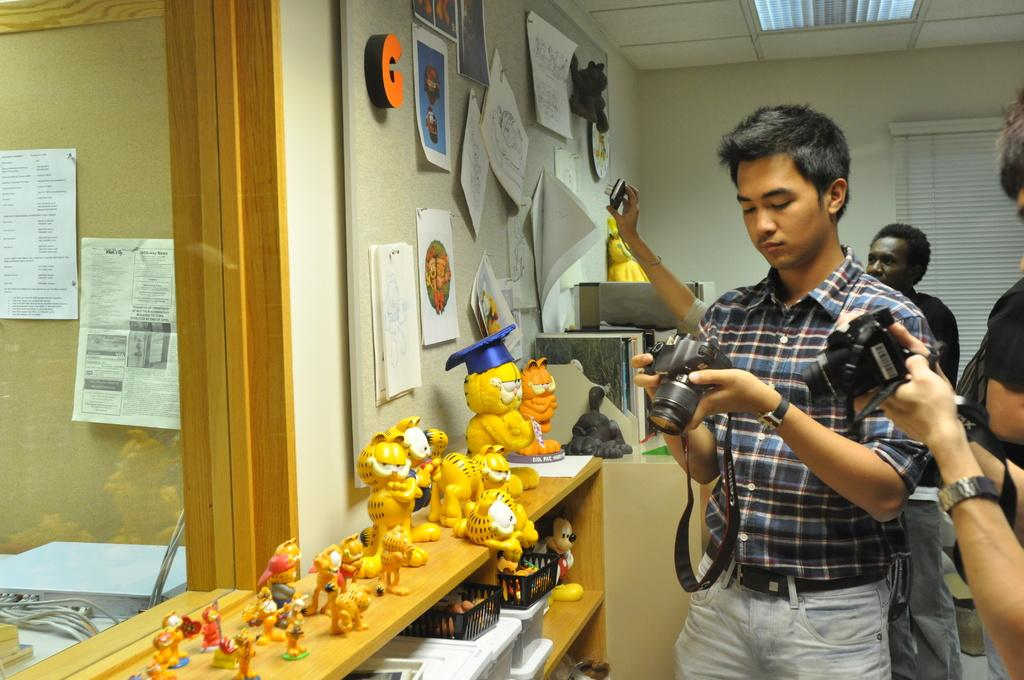<image>
Render a clear and concise summary of the photo. people with cameras taking pictures of cat figures under an orange letter G 